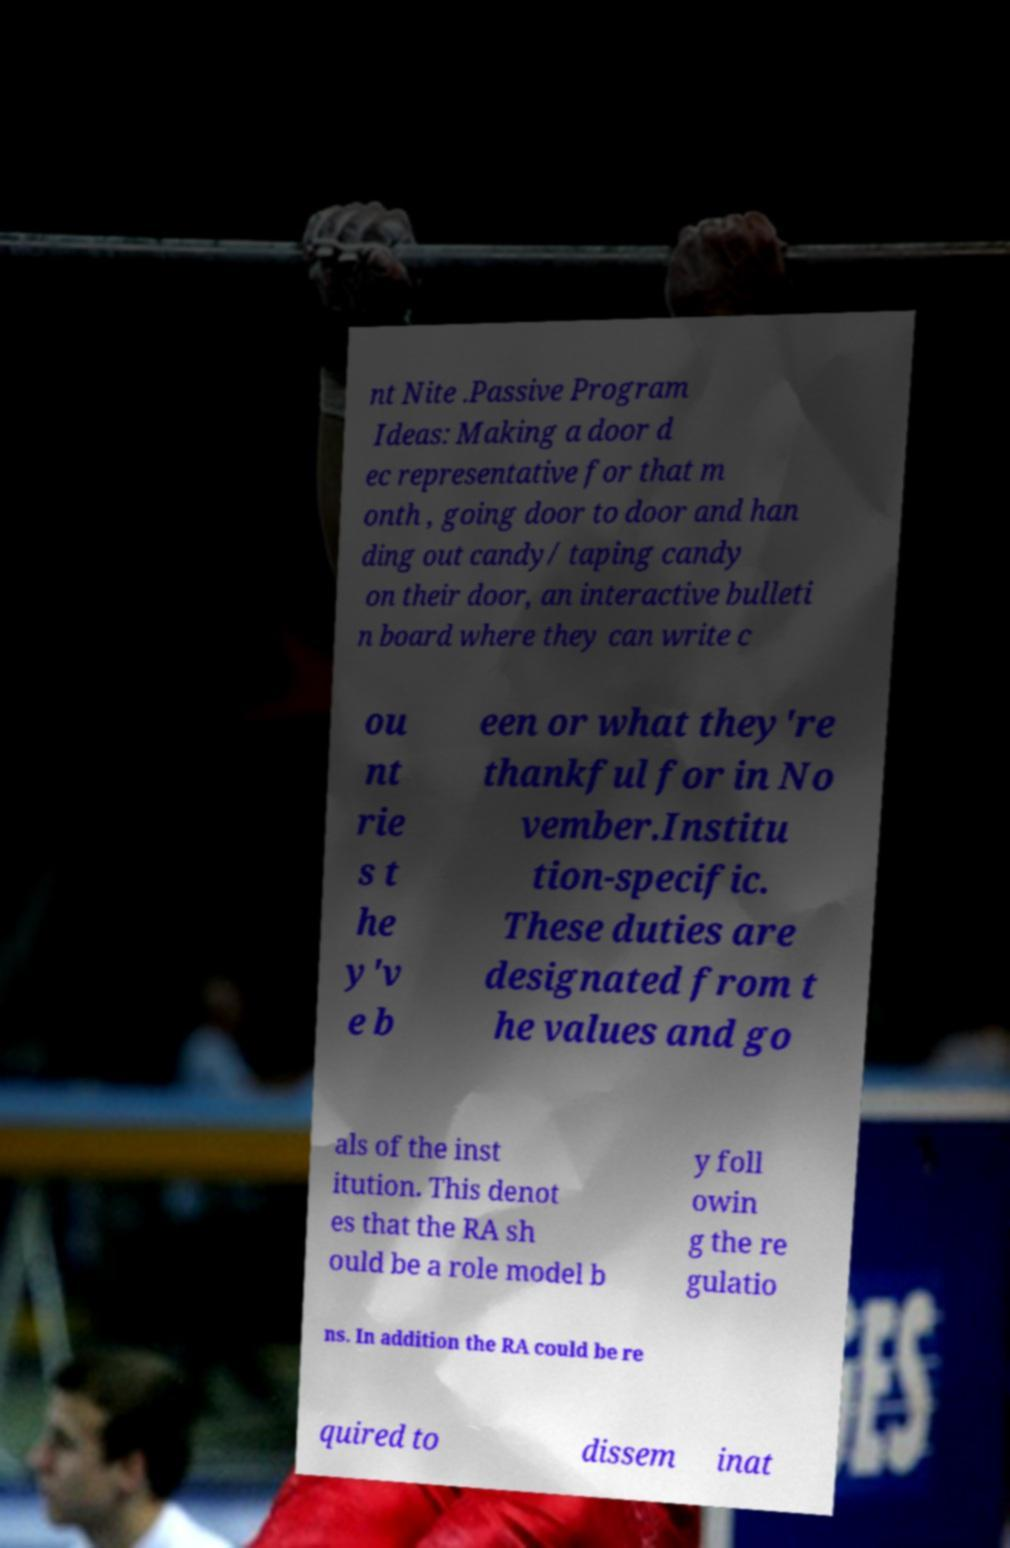Can you read and provide the text displayed in the image?This photo seems to have some interesting text. Can you extract and type it out for me? nt Nite .Passive Program Ideas: Making a door d ec representative for that m onth , going door to door and han ding out candy/ taping candy on their door, an interactive bulleti n board where they can write c ou nt rie s t he y'v e b een or what they're thankful for in No vember.Institu tion-specific. These duties are designated from t he values and go als of the inst itution. This denot es that the RA sh ould be a role model b y foll owin g the re gulatio ns. In addition the RA could be re quired to dissem inat 